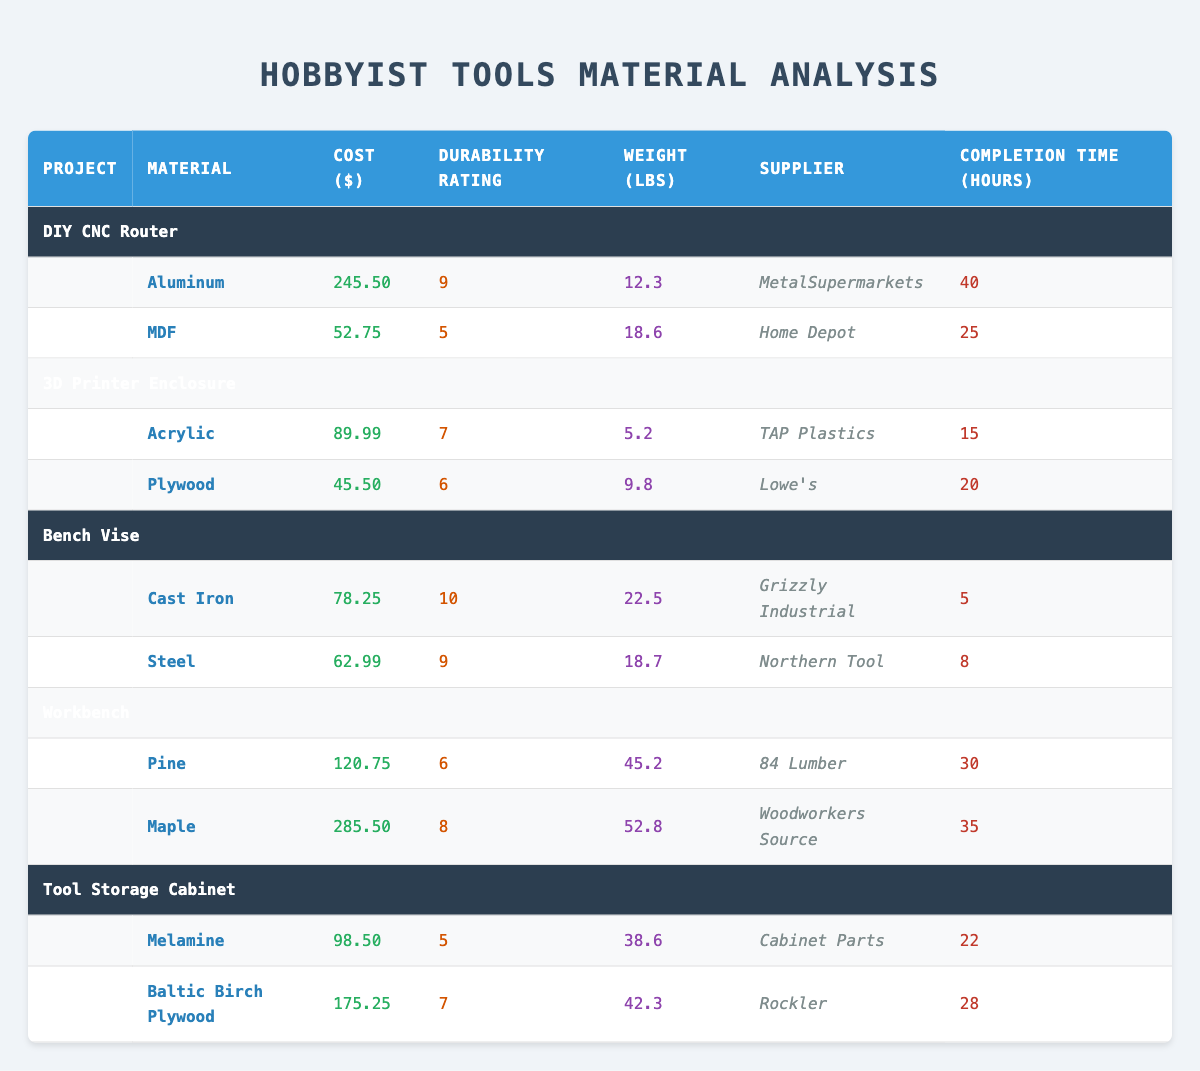What is the material with the highest durability rating? The table shows durability ratings for materials used in various projects. Scanning through the "Durability Rating" column, we find that "Cast Iron" for the "Bench Vise" project has the highest durability rating of 10.
Answer: Cast Iron What is the cost of materials for the "Tool Storage Cabinet" project? For the "Tool Storage Cabinet" project, the costs of materials are as follows: Melamine costs 98.50 and Baltic Birch Plywood costs 175.25. Summing these gives 98.50 + 175.25 = 273.75.
Answer: 273.75 Is the "3D Printer Enclosure" project more expensive than the "DIY CNC Router" project? The costs for the materials in "3D Printer Enclosure" are 89.99 (Acrylic) and 45.50 (Plywood), adding to a total of 135.49. For "DIY CNC Router," the costs are 245.50 (Aluminum) and 52.75 (MDF), totaling 298.25. Since 135.49 is less than 298.25, the statement is false.
Answer: No Which supplier provided the material with the lowest cost? Scanning the "Cost ($)" column reveals that "Plywood" used in the "3D Printer Enclosure" project has the lowest cost of 45.50. The corresponding supplier is Lowe's.
Answer: Lowe's What is the average completion time for the projects listed? To find the average completion time, we sum the completion times: 40 + 25 + 15 + 20 + 5 + 8 + 30 + 35 + 22 + 28 =  228. There are 10 projects, so we divide 228 by 10, giving an average of 22.8 hours.
Answer: 22.8 Which project has materials that are all above a durability rating of 6? Checking the durability ratings, we see "Bench Vise" has ratings of 10 (Cast Iron) and 9 (Steel), which both exceed 6. The "Tool Storage Cabinet" project has a rating of 5 (Melamine), which does not count. Thus, only "Bench Vise" meets the criteria.
Answer: Bench Vise What is the total weight of all materials used in the "Workbench" project? In the "Workbench" project, the materials are Pine with a weight of 45.2 lbs and Maple with a weight of 52.8 lbs. Adding these gives 45.2 + 52.8 = 98.0 lbs.
Answer: 98.0 Are all materials used in the "DIY CNC Router" project sourced from the same supplier? The "DIY CNC Router" project has materials from two suppliers: Aluminum from MetalSupermarkets and MDF from Home Depot, indicating they are not all from the same supplier.
Answer: No 